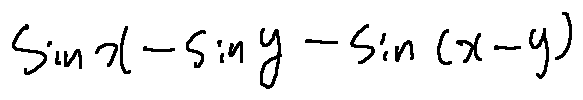<formula> <loc_0><loc_0><loc_500><loc_500>\sin x - \sin y - \sin ( x - y )</formula> 